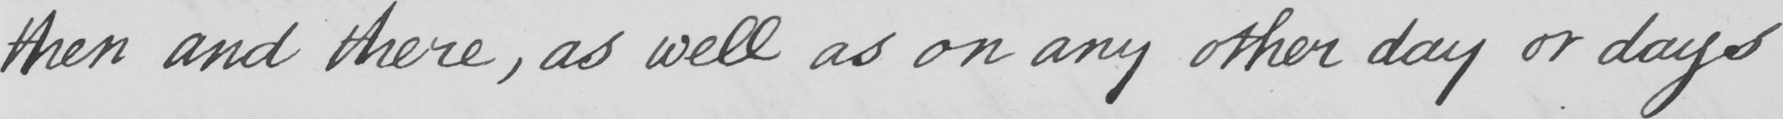What text is written in this handwritten line? then and there , as well as on any other day or days 